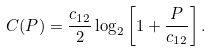<formula> <loc_0><loc_0><loc_500><loc_500>C ( P ) & = \frac { c _ { 1 2 } } { 2 } \log _ { 2 } \left [ 1 + \frac { P } { c _ { 1 2 } } \right ] .</formula> 